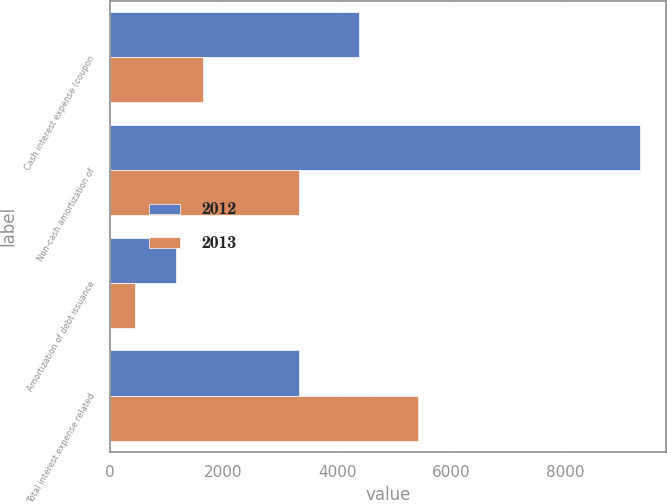Convert chart to OTSL. <chart><loc_0><loc_0><loc_500><loc_500><stacked_bar_chart><ecel><fcel>Cash interest expense (coupon<fcel>Non-cash amortization of<fcel>Amortization of debt issuance<fcel>Total interest expense related<nl><fcel>2012<fcel>4375<fcel>9312<fcel>1158<fcel>3336<nl><fcel>2013<fcel>1641<fcel>3336<fcel>449<fcel>5426<nl></chart> 